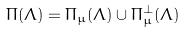<formula> <loc_0><loc_0><loc_500><loc_500>\Pi ( \Lambda ) = \Pi _ { \mu } ( \Lambda ) \cup \Pi ^ { \perp } _ { \mu } ( \Lambda )</formula> 